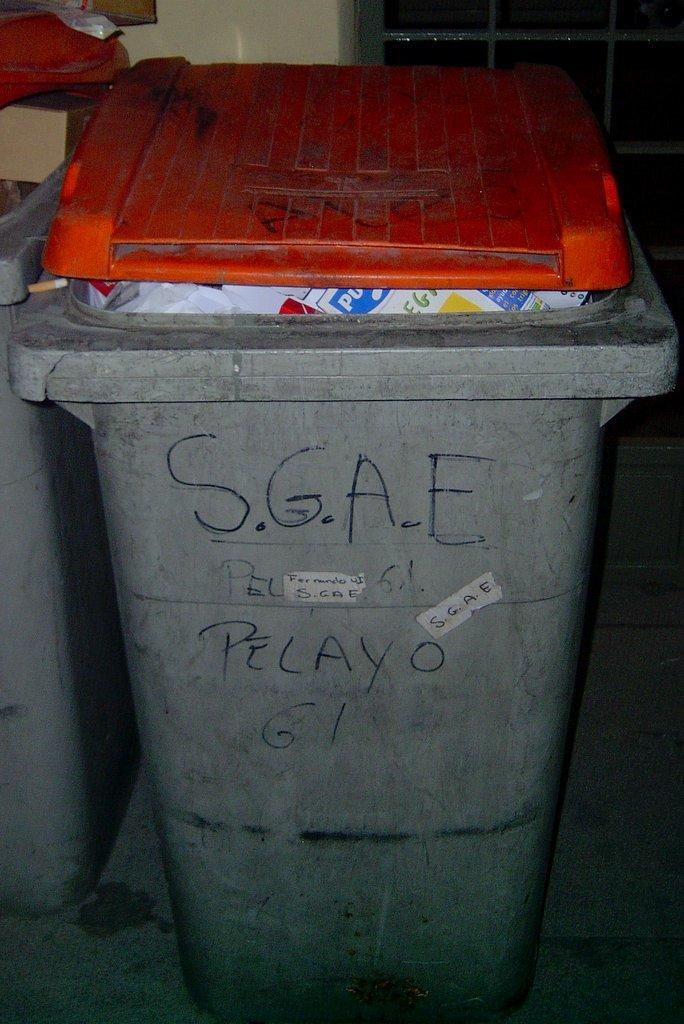What is the acronym frequently on the can?
Offer a terse response. Sgae. 